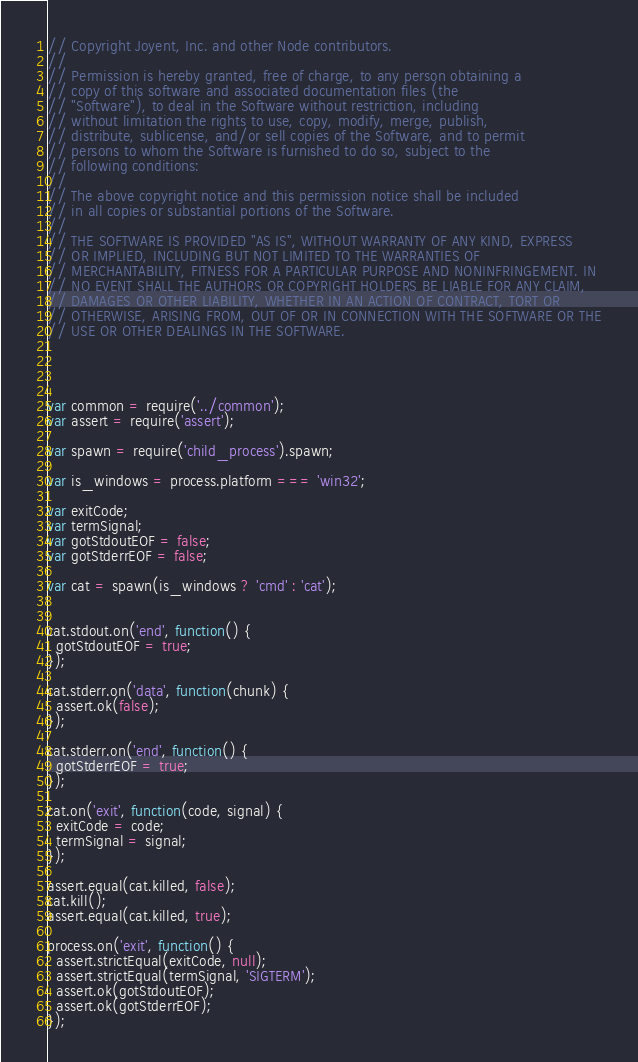<code> <loc_0><loc_0><loc_500><loc_500><_JavaScript_>// Copyright Joyent, Inc. and other Node contributors.
//
// Permission is hereby granted, free of charge, to any person obtaining a
// copy of this software and associated documentation files (the
// "Software"), to deal in the Software without restriction, including
// without limitation the rights to use, copy, modify, merge, publish,
// distribute, sublicense, and/or sell copies of the Software, and to permit
// persons to whom the Software is furnished to do so, subject to the
// following conditions:
//
// The above copyright notice and this permission notice shall be included
// in all copies or substantial portions of the Software.
//
// THE SOFTWARE IS PROVIDED "AS IS", WITHOUT WARRANTY OF ANY KIND, EXPRESS
// OR IMPLIED, INCLUDING BUT NOT LIMITED TO THE WARRANTIES OF
// MERCHANTABILITY, FITNESS FOR A PARTICULAR PURPOSE AND NONINFRINGEMENT. IN
// NO EVENT SHALL THE AUTHORS OR COPYRIGHT HOLDERS BE LIABLE FOR ANY CLAIM,
// DAMAGES OR OTHER LIABILITY, WHETHER IN AN ACTION OF CONTRACT, TORT OR
// OTHERWISE, ARISING FROM, OUT OF OR IN CONNECTION WITH THE SOFTWARE OR THE
// USE OR OTHER DEALINGS IN THE SOFTWARE.




var common = require('../common');
var assert = require('assert');

var spawn = require('child_process').spawn;

var is_windows = process.platform === 'win32';

var exitCode;
var termSignal;
var gotStdoutEOF = false;
var gotStderrEOF = false;

var cat = spawn(is_windows ? 'cmd' : 'cat');


cat.stdout.on('end', function() {
  gotStdoutEOF = true;
});

cat.stderr.on('data', function(chunk) {
  assert.ok(false);
});

cat.stderr.on('end', function() {
  gotStderrEOF = true;
});

cat.on('exit', function(code, signal) {
  exitCode = code;
  termSignal = signal;
});

assert.equal(cat.killed, false);
cat.kill();
assert.equal(cat.killed, true);

process.on('exit', function() {
  assert.strictEqual(exitCode, null);
  assert.strictEqual(termSignal, 'SIGTERM');
  assert.ok(gotStdoutEOF);
  assert.ok(gotStderrEOF);
});
</code> 